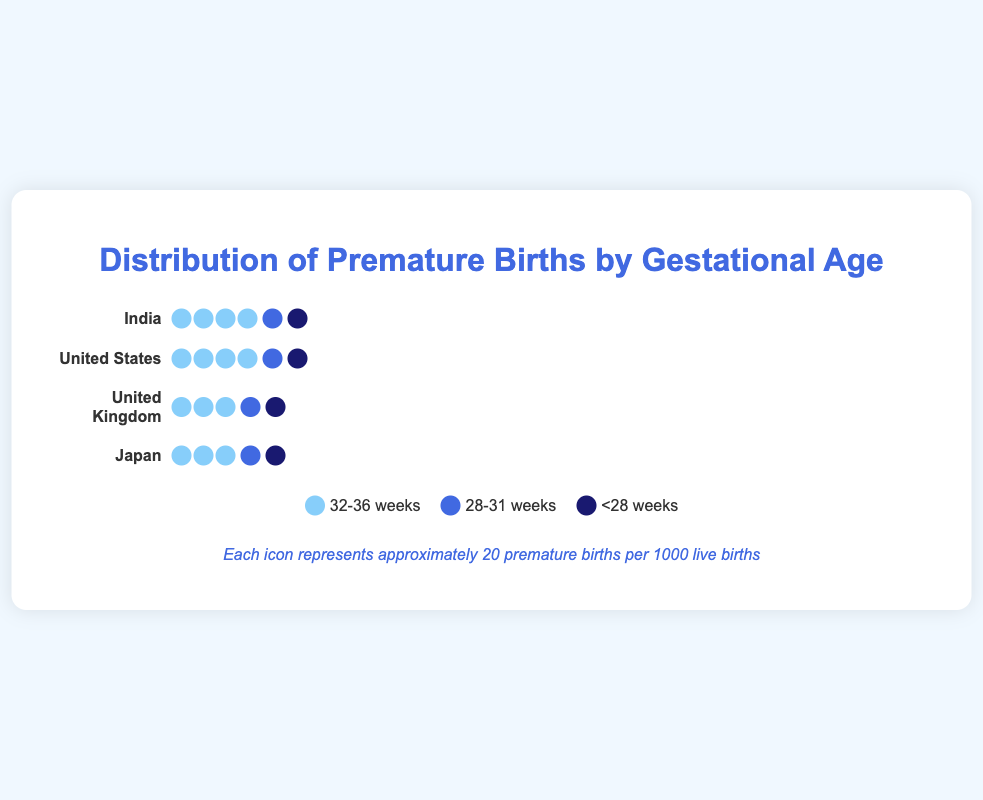What is the title of the figure? The title is displayed at the top of the figure and summarizes the content.
Answer: Distribution of Premature Births by Gestational Age What color represents premature births in the 28-31 weeks gestational age group? The legend at the bottom of the figure provides the color coding for each gestational age group. The color for 28-31 weeks is a medium blue.
Answer: A medium blue Which country has the highest number of premature births in the 32-36 weeks gestational age group? By looking at the count of icons for each country, India has the most icons representing premature births in the 32-36 weeks gestational age group.
Answer: India How many countries are included in this figure? The figure shows one row for each country. Counting these rows gives the total number of countries. There are rows for the United States, United Kingdom, Japan, and India.
Answer: Four Compare the number of premature births in Japan and India for the 28-31 weeks gestational age group. Which country has more? By comparing the count of icons in the 28-31 weeks group for both Japan and India, India has more icons in this category.
Answer: India What is the total number of premature births in the United States for all gestational age groups combined? Sum the number of premature births in each gestational age group for the United States: 70 (32-36 weeks) + 15 (28-31 weeks) + 5 (<28 weeks) = 90.
Answer: 90 Identify the country with the lowest number of premature births in the <28 weeks gestational age group and state the number. By counting the icons for each country in the <28 weeks gestational age group, Japan has the fewest icons, which represent premature births.
Answer: Japan, 3 How does the number of premature births in the United Kingdom for the 32-36 weeks gestational age group compare to the number in the <28 weeks gestational age group? Subtract the number of premature births in the <28 weeks group from the number in the 32-36 weeks group for the United Kingdom: 65 (32-36 weeks) - 4 (<28 weeks) = 61.
Answer: 61 more in the 32-36 weeks group What is the total number of premature births in all countries for the <28 weeks gestational age group? Add the number of premature births in the <28 weeks category for all countries: 5 (US) + 4 (UK) + 3 (Japan) + 8 (India) = 20.
Answer: 20 